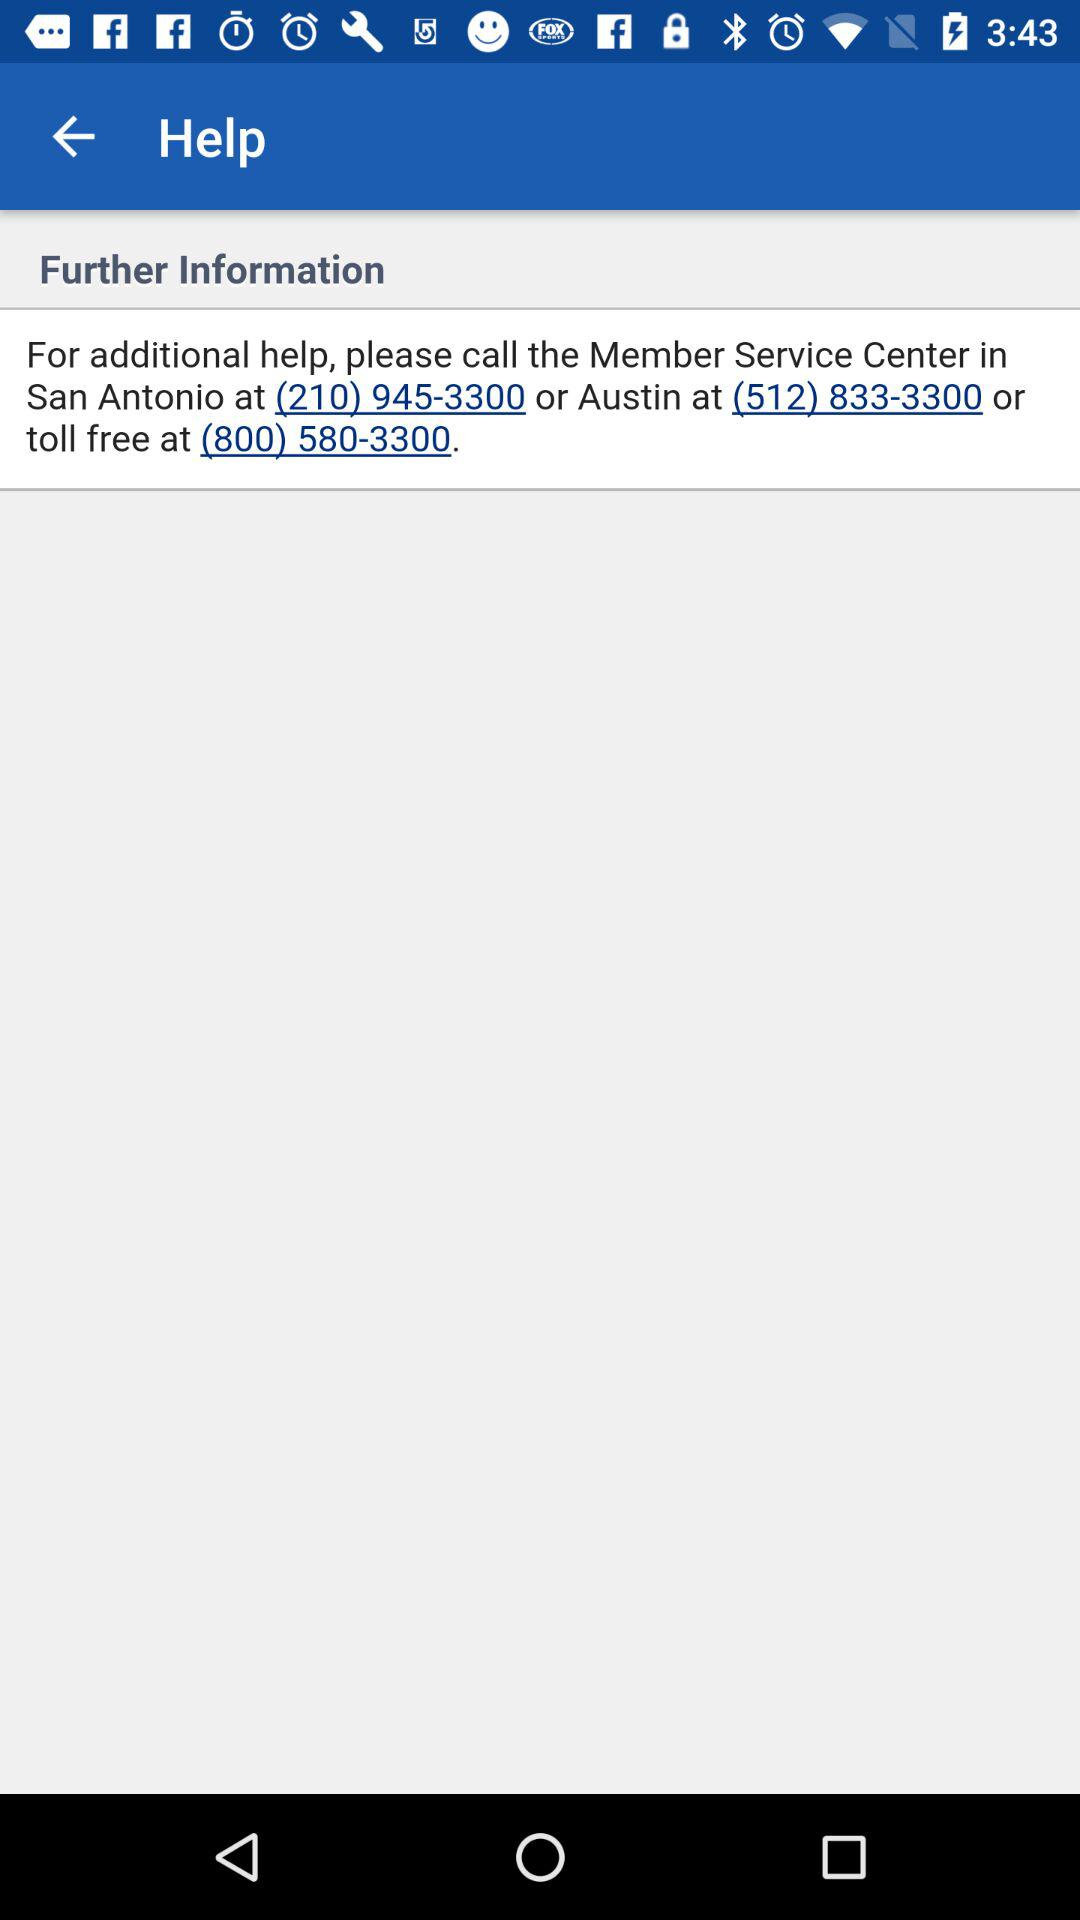What is the toll free number? The toll free number is (800) 580-3300. 